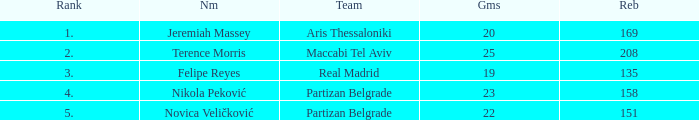How many Rebounds did Novica Veličković get in less than 22 Games? None. 